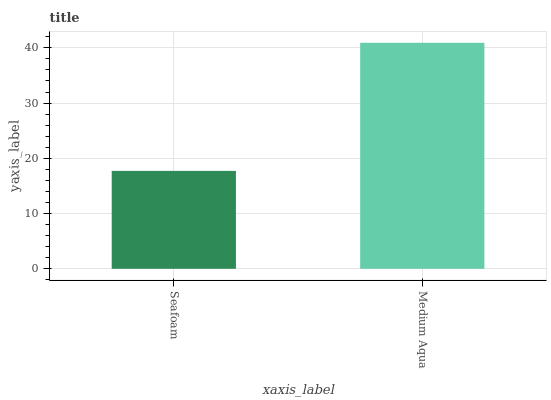Is Seafoam the minimum?
Answer yes or no. Yes. Is Medium Aqua the maximum?
Answer yes or no. Yes. Is Medium Aqua the minimum?
Answer yes or no. No. Is Medium Aqua greater than Seafoam?
Answer yes or no. Yes. Is Seafoam less than Medium Aqua?
Answer yes or no. Yes. Is Seafoam greater than Medium Aqua?
Answer yes or no. No. Is Medium Aqua less than Seafoam?
Answer yes or no. No. Is Medium Aqua the high median?
Answer yes or no. Yes. Is Seafoam the low median?
Answer yes or no. Yes. Is Seafoam the high median?
Answer yes or no. No. Is Medium Aqua the low median?
Answer yes or no. No. 